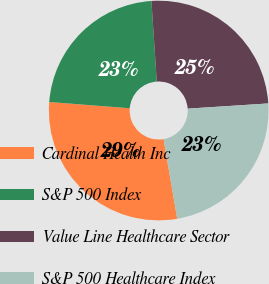Convert chart. <chart><loc_0><loc_0><loc_500><loc_500><pie_chart><fcel>Cardinal Health Inc<fcel>S&P 500 Index<fcel>Value Line Healthcare Sector<fcel>S&P 500 Healthcare Index<nl><fcel>28.94%<fcel>22.71%<fcel>25.03%<fcel>23.33%<nl></chart> 